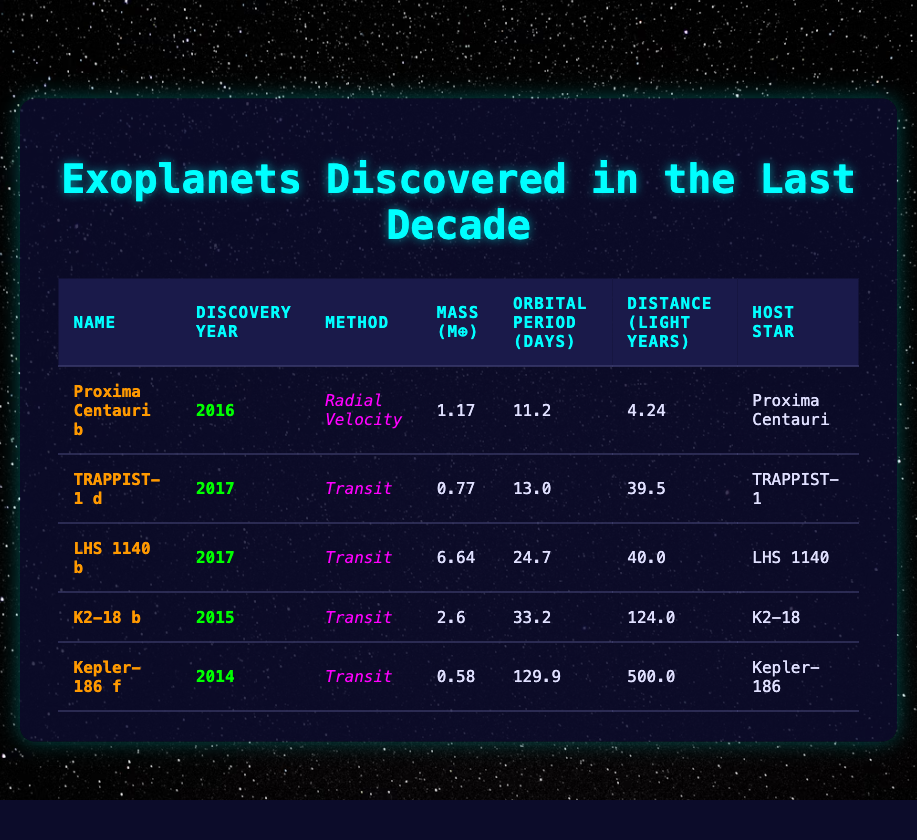What is the method used to discover LHS 1140 b? The method for LHS 1140 b is listed in the table under the "Method" column for that specific row. It shows "Transit" as the discovery method.
Answer: Transit In which year was TRAPPIST-1 d discovered? The discovery year for TRAPPIST-1 d can be found in its respective row in the "Discovery Year" column, which states 2017.
Answer: 2017 How many exoplanets were discovered using the Transit method? There are four entries in the table, and I can count the rows where "Transit" appears in the "Method" column: TRAPPIST-1 d, LHS 1140 b, K2-18 b, and Kepler-186 f. So, there are 4 exoplanets.
Answer: 4 What is the mass of Proxima Centauri b compared to TRAPPIST-1 d? The mass of Proxima Centauri b is 1.17 M⊕ and the mass of TRAPPIST-1 d is 0.77 M⊕. The difference can be calculated as 1.17 - 0.77 = 0.40 M⊕.
Answer: 0.40 M⊕ Which exoplanet has the longest orbital period and what is that period? By reviewing the "Orbital Period" column for each exoplanet, Kepler-186 f shows the longest period at 129.9 days. Therefore, the answer would be Kepler-186 f and the period is 129.9 days.
Answer: Kepler-186 f, 129.9 days Is K2-18 b discovered before or after 2016? To determine this, compare the discovery year for K2-18 b, which is listed as 2015, with 2016. Since 2015 is before 2016, it confirms the timeline.
Answer: Before Which host star is the farthest from Earth? To find the host star that is farthest, compare the "Distance" column for each exoplanet. The highest value is for Kepler-186 f at 500.0 light years, making it the farthest exoplanet from Earth.
Answer: Kepler-186, 500.0 light years How much heavier is LHS 1140 b than Proxima Centauri b? The mass of LHS 1140 b is 6.64 M⊕ and the mass of Proxima Centauri b is 1.17 M⊕. Subtracting gives us 6.64 - 1.17 = 5.47 M⊕.
Answer: 5.47 M⊕ Are there any exoplanets discovered in 2015 that are less massive than 1 M⊕? The only exoplanet we can find from 2015 is K2-18 b with a mass of 2.6 M⊕; since it is not less than 1 M⊕, the answer is no.
Answer: No 